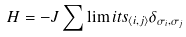<formula> <loc_0><loc_0><loc_500><loc_500>H = - J \sum \lim i t s _ { \left \langle i , j \right \rangle } \delta _ { \sigma _ { i } , \sigma _ { j } }</formula> 